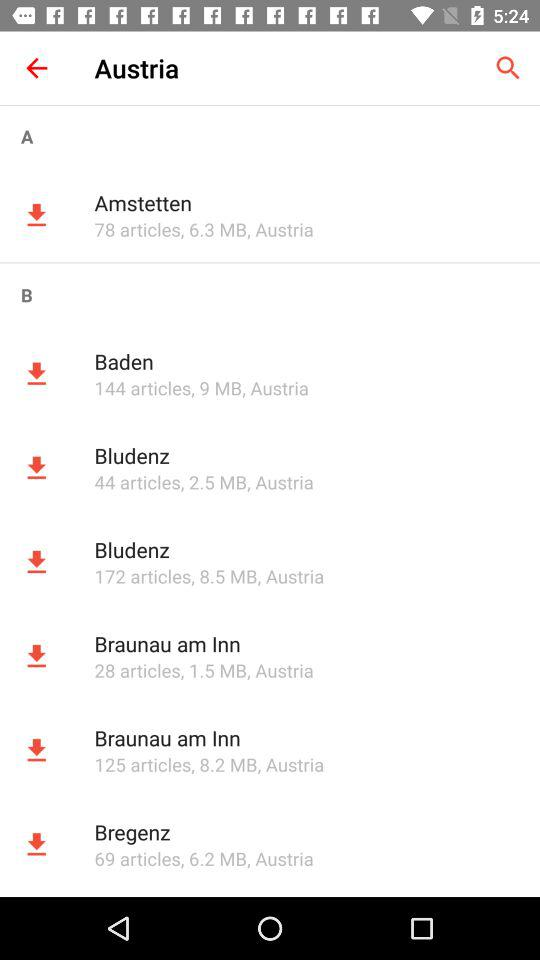What is the size of the "Bludenz"? The size of the "Bludenz" is 2.5 MB. 